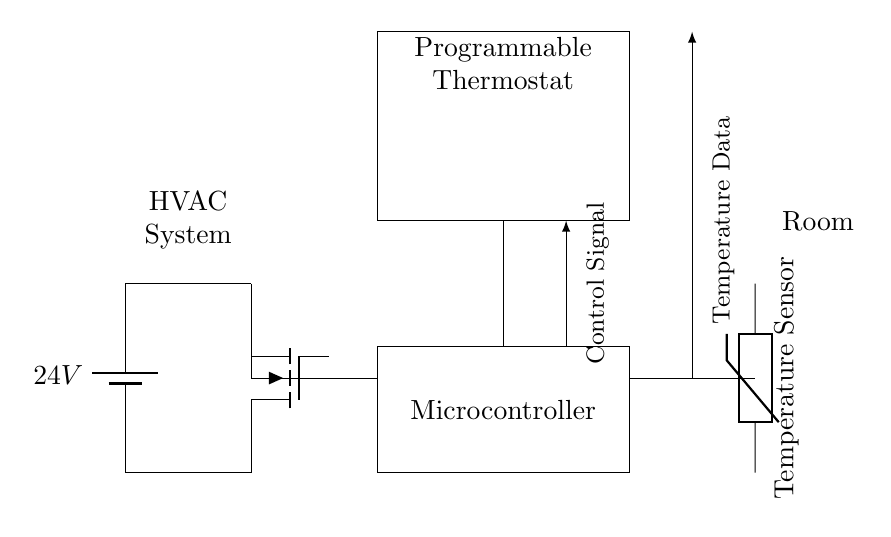What is the voltage source in this circuit? The voltage source in the circuit is labeled as a 24V battery. This is indicated by the label next to the battery component in the diagram.
Answer: 24V What component is responsible for controlling the HVAC system? The component responsible for controlling the HVAC system is the programmable thermostat, as shown in the rectangle labeled "Programmable Thermostat." It is connected to both the microcontroller and the HVAC system.
Answer: Programmable Thermostat How many main components are in this circuit? The main components in the circuit include the HVAC system, programmable thermostat, microcontroller, and temperature sensor. Counting these components results in a total of four.
Answer: Four What is the function of the temperature sensor in this circuit? The function of the temperature sensor is to measure the temperature, as indicated by the label "Temperature Sensor." This sensor provides data back to the thermostat for energy consumption optimization.
Answer: Measure temperature What type of control signal does the microcontroller generate? The control signal generated by the microcontroller is used to operate the HVAC system. This is indicated by the arrow labeled "Control Signal" that points from the microcontroller to the thermostat.
Answer: Control signal What type of sensor is used for temperature measurement in this circuit? The sensor used for temperature measurement is a thermistor, as depicted in the diagram. The label "thermistor" identifies its type and function in this application.
Answer: Thermistor What is the primary purpose of this circuit? The primary purpose of this circuit is to optimize HVAC energy consumption through programmable control based on temperature data. This is inferred from the interconnections between the thermostat, microcontroller, and temperature sensor.
Answer: Optimize HVAC energy consumption 